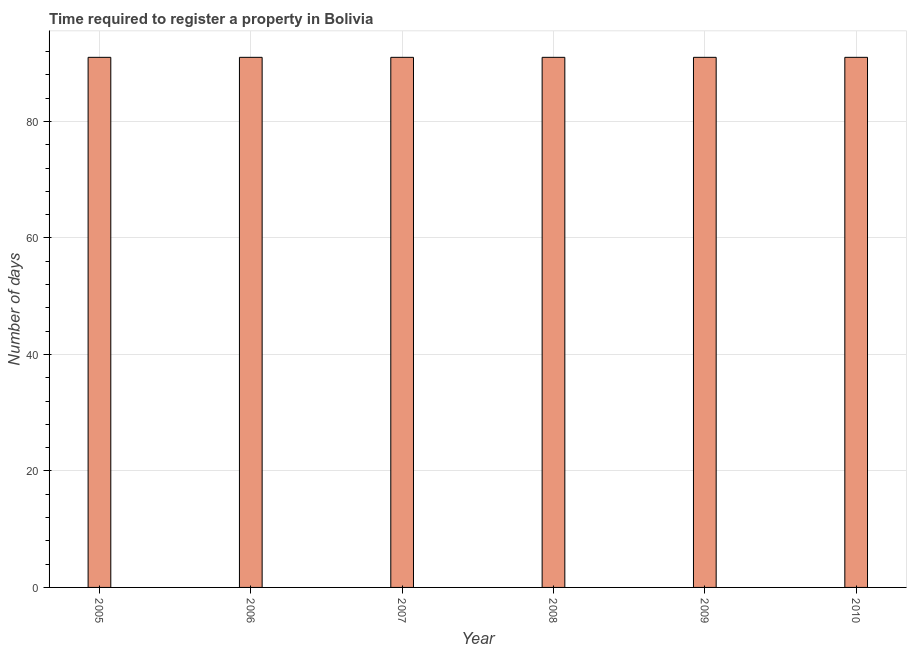Does the graph contain grids?
Your response must be concise. Yes. What is the title of the graph?
Give a very brief answer. Time required to register a property in Bolivia. What is the label or title of the X-axis?
Ensure brevity in your answer.  Year. What is the label or title of the Y-axis?
Your answer should be compact. Number of days. What is the number of days required to register property in 2010?
Your response must be concise. 91. Across all years, what is the maximum number of days required to register property?
Provide a succinct answer. 91. Across all years, what is the minimum number of days required to register property?
Provide a short and direct response. 91. In which year was the number of days required to register property maximum?
Your answer should be very brief. 2005. In which year was the number of days required to register property minimum?
Your answer should be very brief. 2005. What is the sum of the number of days required to register property?
Make the answer very short. 546. What is the average number of days required to register property per year?
Give a very brief answer. 91. What is the median number of days required to register property?
Ensure brevity in your answer.  91. Is the number of days required to register property in 2005 less than that in 2010?
Your answer should be compact. No. Is the difference between the number of days required to register property in 2006 and 2010 greater than the difference between any two years?
Provide a short and direct response. Yes. What is the difference between the highest and the second highest number of days required to register property?
Your answer should be very brief. 0. Is the sum of the number of days required to register property in 2006 and 2008 greater than the maximum number of days required to register property across all years?
Make the answer very short. Yes. What is the difference between the highest and the lowest number of days required to register property?
Offer a very short reply. 0. How many bars are there?
Keep it short and to the point. 6. What is the Number of days of 2005?
Make the answer very short. 91. What is the Number of days of 2006?
Keep it short and to the point. 91. What is the Number of days of 2007?
Your response must be concise. 91. What is the Number of days of 2008?
Your response must be concise. 91. What is the Number of days of 2009?
Make the answer very short. 91. What is the Number of days in 2010?
Provide a short and direct response. 91. What is the difference between the Number of days in 2006 and 2009?
Offer a very short reply. 0. What is the difference between the Number of days in 2007 and 2008?
Give a very brief answer. 0. What is the difference between the Number of days in 2007 and 2009?
Keep it short and to the point. 0. What is the difference between the Number of days in 2007 and 2010?
Offer a terse response. 0. What is the difference between the Number of days in 2009 and 2010?
Give a very brief answer. 0. What is the ratio of the Number of days in 2005 to that in 2006?
Provide a succinct answer. 1. What is the ratio of the Number of days in 2005 to that in 2007?
Your answer should be compact. 1. What is the ratio of the Number of days in 2005 to that in 2008?
Ensure brevity in your answer.  1. What is the ratio of the Number of days in 2005 to that in 2009?
Make the answer very short. 1. What is the ratio of the Number of days in 2005 to that in 2010?
Give a very brief answer. 1. What is the ratio of the Number of days in 2006 to that in 2007?
Provide a short and direct response. 1. What is the ratio of the Number of days in 2006 to that in 2008?
Your response must be concise. 1. What is the ratio of the Number of days in 2009 to that in 2010?
Give a very brief answer. 1. 